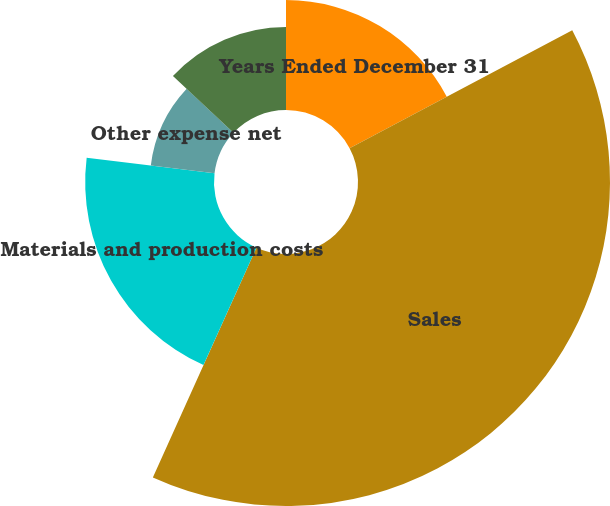Convert chart. <chart><loc_0><loc_0><loc_500><loc_500><pie_chart><fcel>Years Ended December 31<fcel>Sales<fcel>Materials and production costs<fcel>Other expense net<fcel>Income before taxes (1)<nl><fcel>17.24%<fcel>39.5%<fcel>20.19%<fcel>10.06%<fcel>13.01%<nl></chart> 